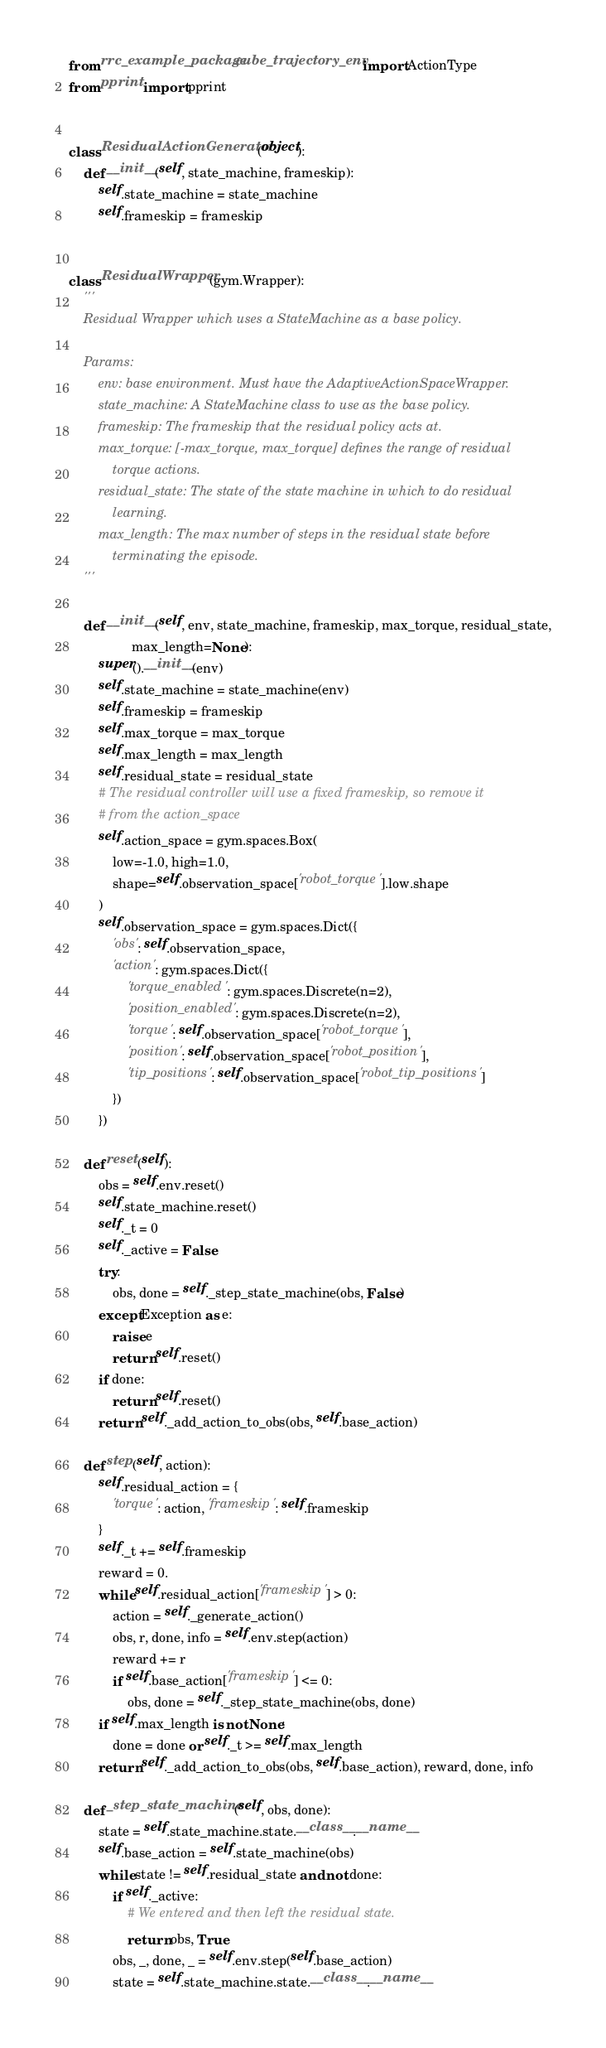Convert code to text. <code><loc_0><loc_0><loc_500><loc_500><_Python_>from rrc_example_package.cube_trajectory_env import ActionType
from pprint import pprint


class ResidualActionGenerator(object):
    def __init__(self, state_machine, frameskip):
        self.state_machine = state_machine
        self.frameskip = frameskip


class ResidualWrapper(gym.Wrapper):
    '''
    Residual Wrapper which uses a StateMachine as a base policy.

    Params:
        env: base environment. Must have the AdaptiveActionSpaceWrapper.
        state_machine: A StateMachine class to use as the base policy.
        frameskip: The frameskip that the residual policy acts at.
        max_torque: [-max_torque, max_torque] defines the range of residual
            torque actions.
        residual_state: The state of the state machine in which to do residual
            learning.
        max_length: The max number of steps in the residual state before
            terminating the episode.
    '''

    def __init__(self, env, state_machine, frameskip, max_torque, residual_state,
                 max_length=None):
        super().__init__(env)
        self.state_machine = state_machine(env)
        self.frameskip = frameskip
        self.max_torque = max_torque
        self.max_length = max_length
        self.residual_state = residual_state
        # The residual controller will use a fixed frameskip, so remove it
        # from the action_space
        self.action_space = gym.spaces.Box(
            low=-1.0, high=1.0,
            shape=self.observation_space['robot_torque'].low.shape
        )
        self.observation_space = gym.spaces.Dict({
            'obs': self.observation_space,
            'action': gym.spaces.Dict({
                'torque_enabled': gym.spaces.Discrete(n=2),
                'position_enabled': gym.spaces.Discrete(n=2),
                'torque': self.observation_space['robot_torque'],
                'position': self.observation_space['robot_position'],
                'tip_positions': self.observation_space['robot_tip_positions']
            })
        })

    def reset(self):
        obs = self.env.reset()
        self.state_machine.reset()
        self._t = 0
        self._active = False
        try:
            obs, done = self._step_state_machine(obs, False)
        except Exception as e:
            raise e
            return self.reset()
        if done:
            return self.reset()
        return self._add_action_to_obs(obs, self.base_action)

    def step(self, action):
        self.residual_action = {
            'torque': action, 'frameskip': self.frameskip
        }
        self._t += self.frameskip
        reward = 0.
        while self.residual_action['frameskip'] > 0:
            action = self._generate_action()
            obs, r, done, info = self.env.step(action)
            reward += r
            if self.base_action['frameskip'] <= 0:
                obs, done = self._step_state_machine(obs, done)
        if self.max_length is not None:
            done = done or self._t >= self.max_length
        return self._add_action_to_obs(obs, self.base_action), reward, done, info

    def _step_state_machine(self, obs, done):
        state = self.state_machine.state.__class__.__name__
        self.base_action = self.state_machine(obs)
        while state != self.residual_state and not done:
            if self._active:
                # We entered and then left the residual state.
                return obs, True
            obs, _, done, _ = self.env.step(self.base_action)
            state = self.state_machine.state.__class__.__name__</code> 